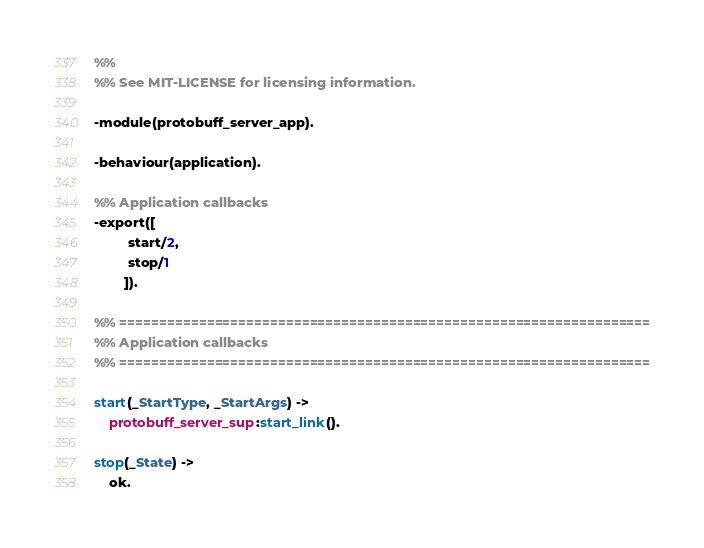Convert code to text. <code><loc_0><loc_0><loc_500><loc_500><_Erlang_>%%
%% See MIT-LICENSE for licensing information.

-module(protobuff_server_app).

-behaviour(application).

%% Application callbacks
-export([
         start/2,
         stop/1
        ]).

%% ===================================================================
%% Application callbacks
%% ===================================================================

start(_StartType, _StartArgs) ->
    protobuff_server_sup:start_link().

stop(_State) ->
    ok.
</code> 